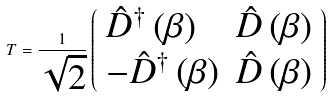<formula> <loc_0><loc_0><loc_500><loc_500>T = \frac { 1 } { \sqrt { 2 } } \left ( \begin{array} { l l } \hat { D } ^ { \dag } \left ( \beta \right ) & \hat { D } \left ( \beta \right ) \\ - \hat { D } ^ { \dag } \left ( \beta \right ) & \hat { D } \left ( \beta \right ) \end{array} \right )</formula> 